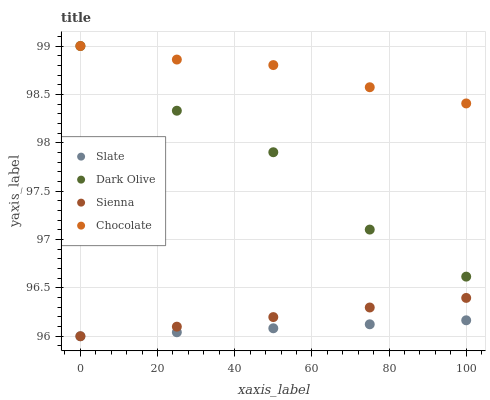Does Slate have the minimum area under the curve?
Answer yes or no. Yes. Does Chocolate have the maximum area under the curve?
Answer yes or no. Yes. Does Dark Olive have the minimum area under the curve?
Answer yes or no. No. Does Dark Olive have the maximum area under the curve?
Answer yes or no. No. Is Slate the smoothest?
Answer yes or no. Yes. Is Dark Olive the roughest?
Answer yes or no. Yes. Is Dark Olive the smoothest?
Answer yes or no. No. Is Slate the roughest?
Answer yes or no. No. Does Sienna have the lowest value?
Answer yes or no. Yes. Does Dark Olive have the lowest value?
Answer yes or no. No. Does Chocolate have the highest value?
Answer yes or no. Yes. Does Slate have the highest value?
Answer yes or no. No. Is Slate less than Dark Olive?
Answer yes or no. Yes. Is Dark Olive greater than Sienna?
Answer yes or no. Yes. Does Dark Olive intersect Chocolate?
Answer yes or no. Yes. Is Dark Olive less than Chocolate?
Answer yes or no. No. Is Dark Olive greater than Chocolate?
Answer yes or no. No. Does Slate intersect Dark Olive?
Answer yes or no. No. 